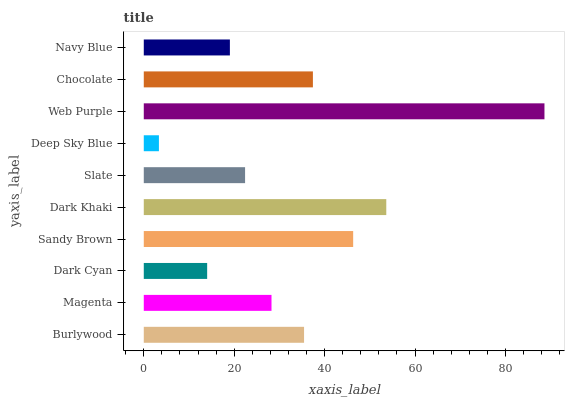Is Deep Sky Blue the minimum?
Answer yes or no. Yes. Is Web Purple the maximum?
Answer yes or no. Yes. Is Magenta the minimum?
Answer yes or no. No. Is Magenta the maximum?
Answer yes or no. No. Is Burlywood greater than Magenta?
Answer yes or no. Yes. Is Magenta less than Burlywood?
Answer yes or no. Yes. Is Magenta greater than Burlywood?
Answer yes or no. No. Is Burlywood less than Magenta?
Answer yes or no. No. Is Burlywood the high median?
Answer yes or no. Yes. Is Magenta the low median?
Answer yes or no. Yes. Is Deep Sky Blue the high median?
Answer yes or no. No. Is Dark Cyan the low median?
Answer yes or no. No. 